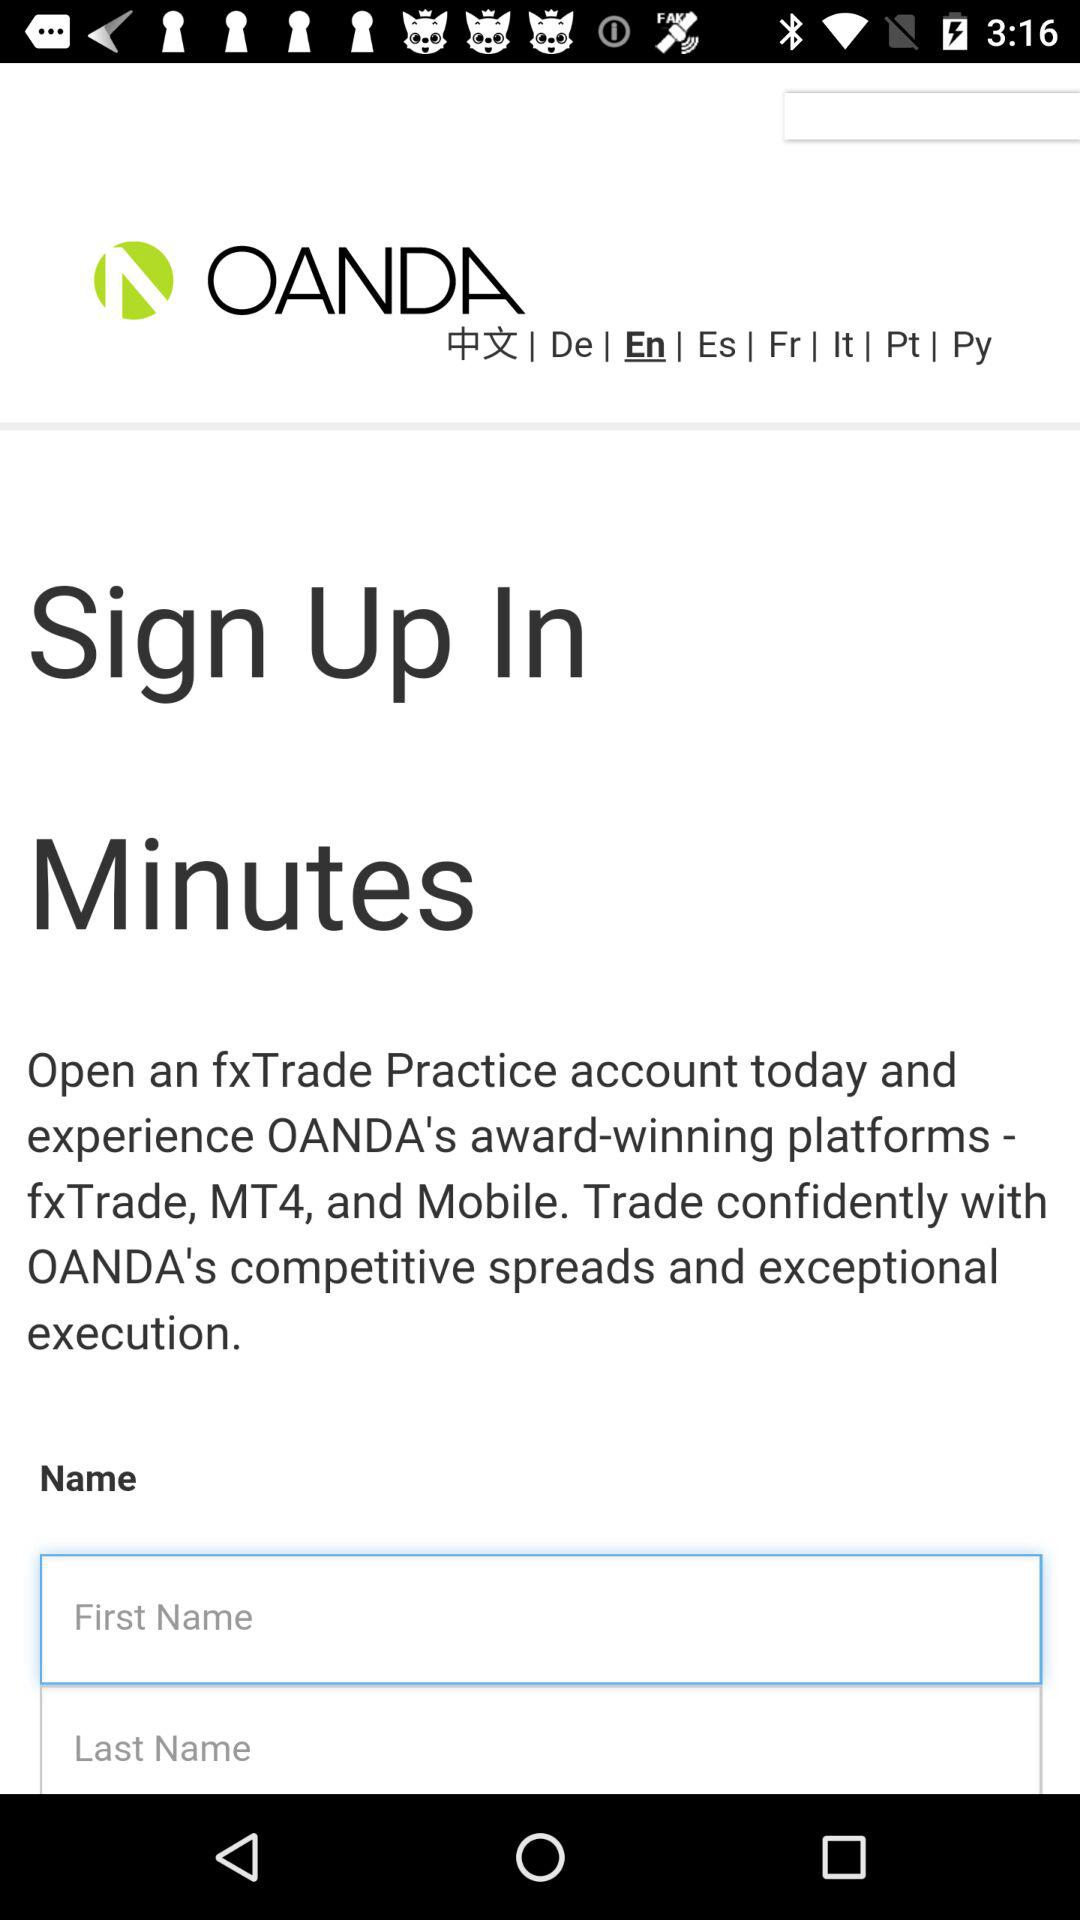Is there any information about the type of accounts available through this service? Yes, the image references an 'fxTrade Practice account' which suggests that at least one type of account offered is a practice or demo account for users to simulate forex trading without financial risk. 